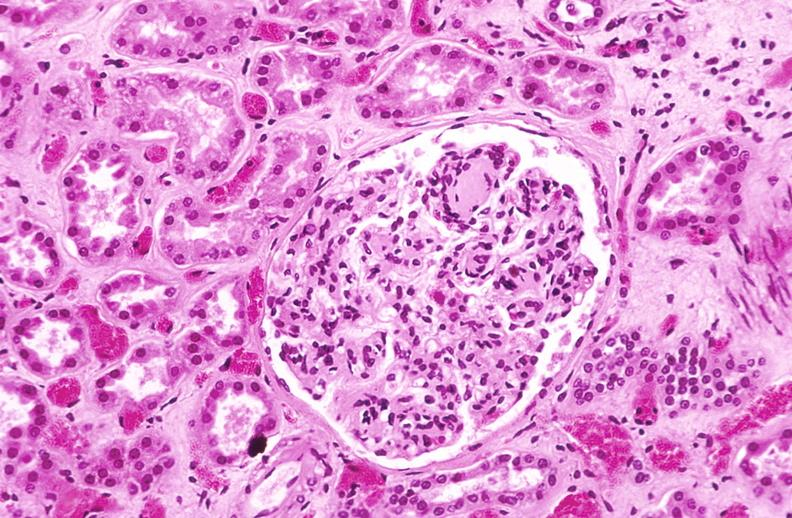what does this image show?
Answer the question using a single word or phrase. Kidney glomerulus 